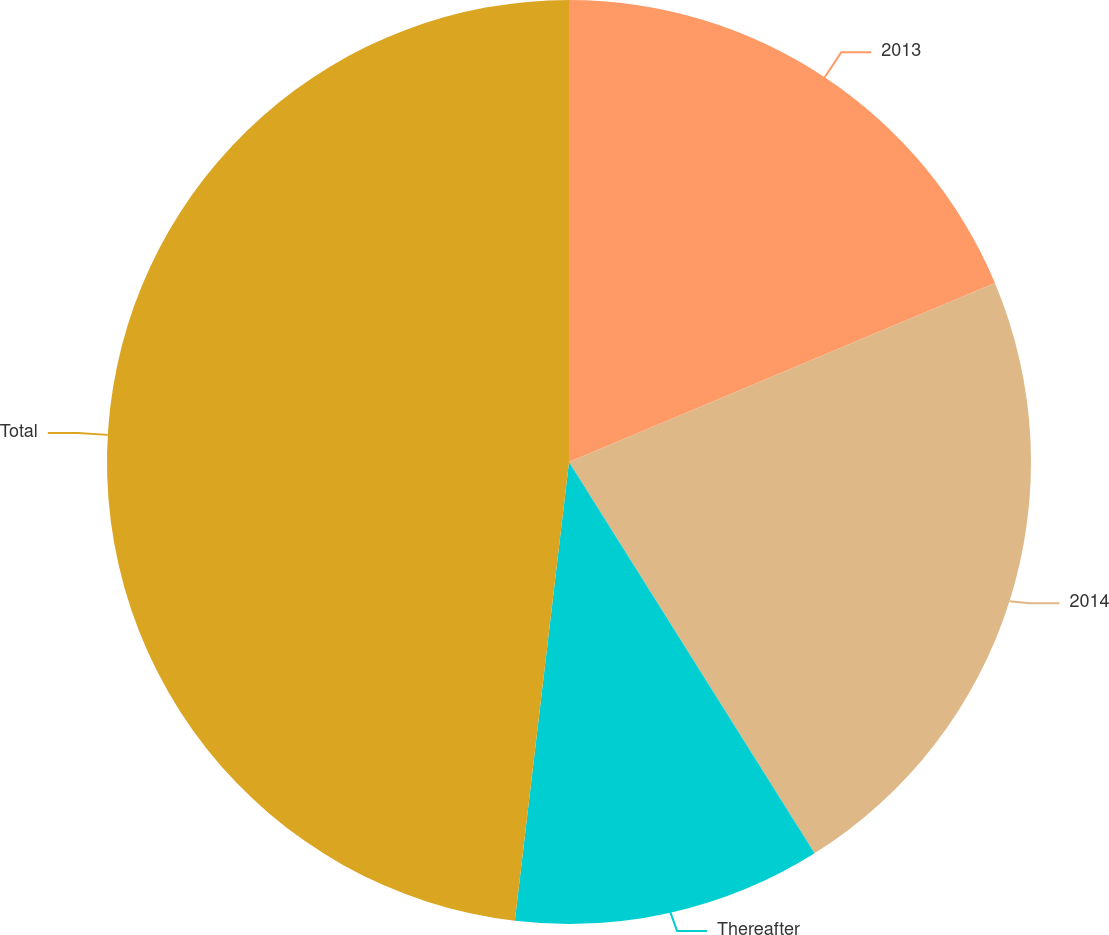Convert chart to OTSL. <chart><loc_0><loc_0><loc_500><loc_500><pie_chart><fcel>2013<fcel>2014<fcel>Thereafter<fcel>Total<nl><fcel>18.67%<fcel>22.41%<fcel>10.79%<fcel>48.13%<nl></chart> 